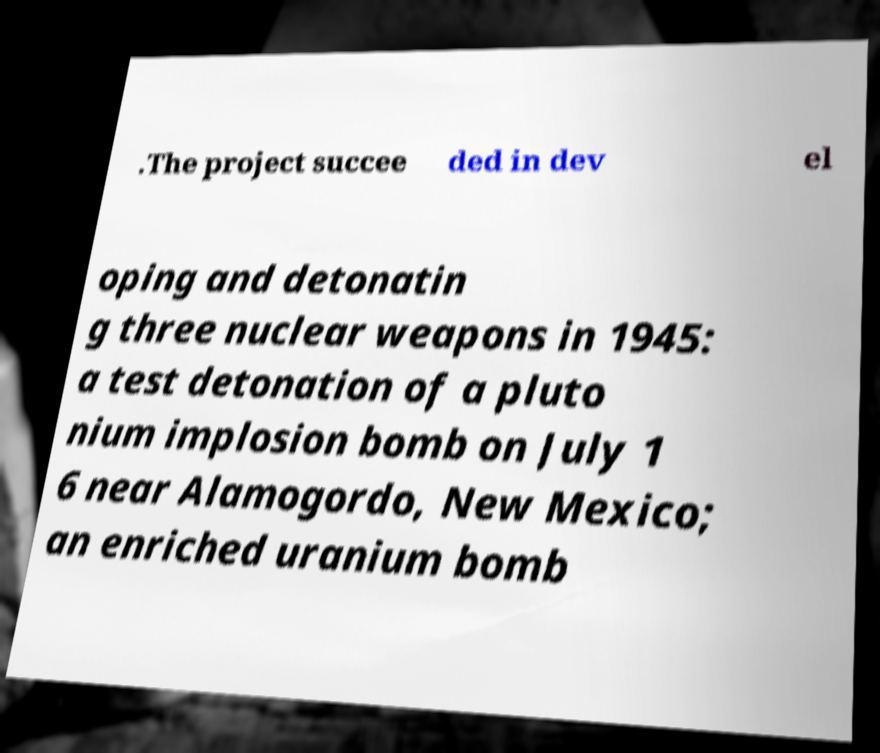Could you assist in decoding the text presented in this image and type it out clearly? .The project succee ded in dev el oping and detonatin g three nuclear weapons in 1945: a test detonation of a pluto nium implosion bomb on July 1 6 near Alamogordo, New Mexico; an enriched uranium bomb 